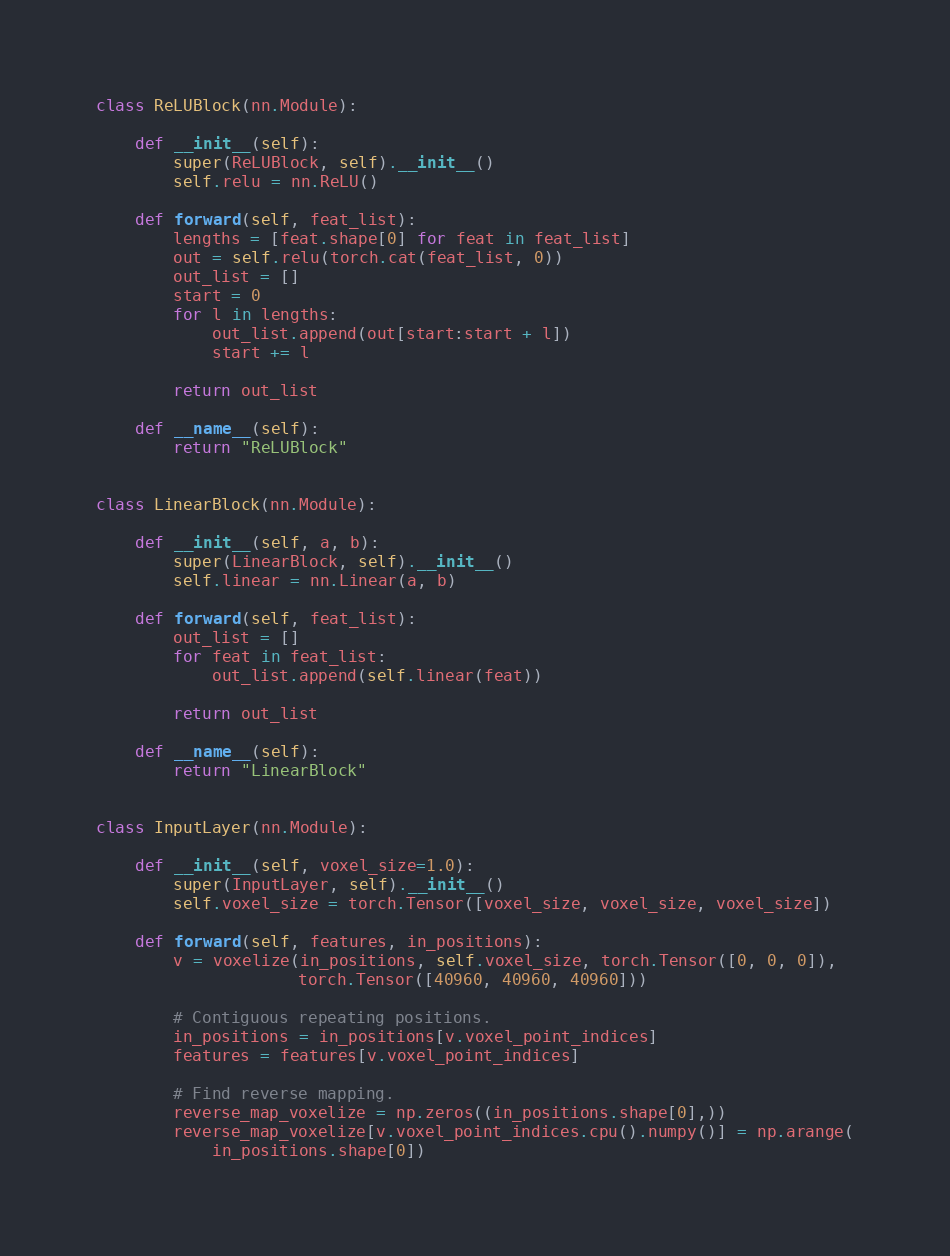Convert code to text. <code><loc_0><loc_0><loc_500><loc_500><_Python_>
class ReLUBlock(nn.Module):

    def __init__(self):
        super(ReLUBlock, self).__init__()
        self.relu = nn.ReLU()

    def forward(self, feat_list):
        lengths = [feat.shape[0] for feat in feat_list]
        out = self.relu(torch.cat(feat_list, 0))
        out_list = []
        start = 0
        for l in lengths:
            out_list.append(out[start:start + l])
            start += l

        return out_list

    def __name__(self):
        return "ReLUBlock"


class LinearBlock(nn.Module):

    def __init__(self, a, b):
        super(LinearBlock, self).__init__()
        self.linear = nn.Linear(a, b)

    def forward(self, feat_list):
        out_list = []
        for feat in feat_list:
            out_list.append(self.linear(feat))

        return out_list

    def __name__(self):
        return "LinearBlock"


class InputLayer(nn.Module):

    def __init__(self, voxel_size=1.0):
        super(InputLayer, self).__init__()
        self.voxel_size = torch.Tensor([voxel_size, voxel_size, voxel_size])

    def forward(self, features, in_positions):
        v = voxelize(in_positions, self.voxel_size, torch.Tensor([0, 0, 0]),
                     torch.Tensor([40960, 40960, 40960]))

        # Contiguous repeating positions.
        in_positions = in_positions[v.voxel_point_indices]
        features = features[v.voxel_point_indices]

        # Find reverse mapping.
        reverse_map_voxelize = np.zeros((in_positions.shape[0],))
        reverse_map_voxelize[v.voxel_point_indices.cpu().numpy()] = np.arange(
            in_positions.shape[0])</code> 